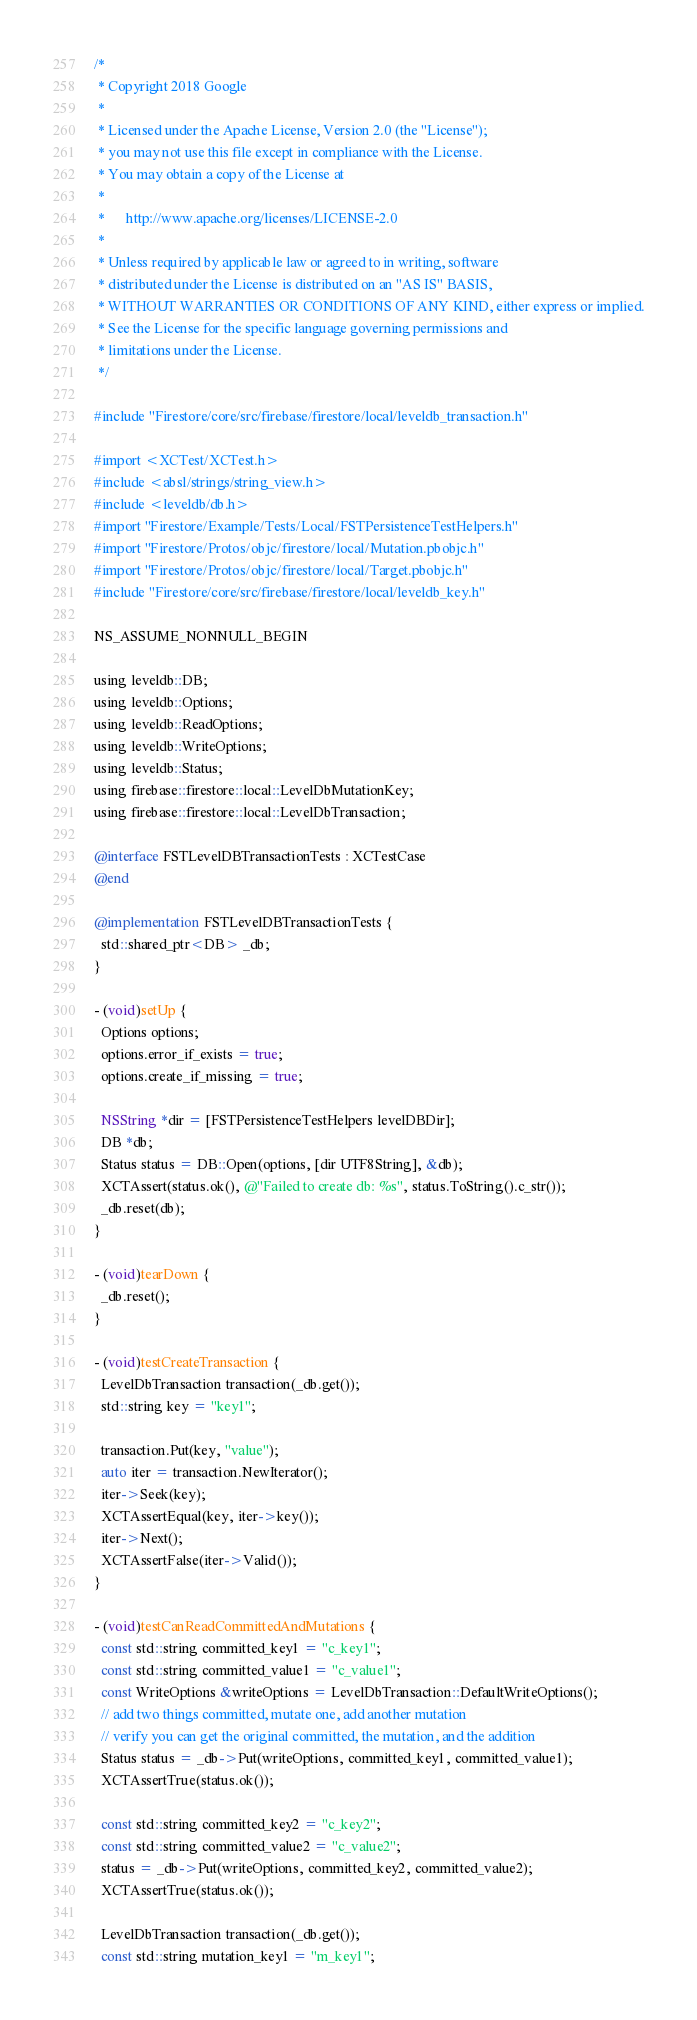<code> <loc_0><loc_0><loc_500><loc_500><_ObjectiveC_>/*
 * Copyright 2018 Google
 *
 * Licensed under the Apache License, Version 2.0 (the "License");
 * you may not use this file except in compliance with the License.
 * You may obtain a copy of the License at
 *
 *      http://www.apache.org/licenses/LICENSE-2.0
 *
 * Unless required by applicable law or agreed to in writing, software
 * distributed under the License is distributed on an "AS IS" BASIS,
 * WITHOUT WARRANTIES OR CONDITIONS OF ANY KIND, either express or implied.
 * See the License for the specific language governing permissions and
 * limitations under the License.
 */

#include "Firestore/core/src/firebase/firestore/local/leveldb_transaction.h"

#import <XCTest/XCTest.h>
#include <absl/strings/string_view.h>
#include <leveldb/db.h>
#import "Firestore/Example/Tests/Local/FSTPersistenceTestHelpers.h"
#import "Firestore/Protos/objc/firestore/local/Mutation.pbobjc.h"
#import "Firestore/Protos/objc/firestore/local/Target.pbobjc.h"
#include "Firestore/core/src/firebase/firestore/local/leveldb_key.h"

NS_ASSUME_NONNULL_BEGIN

using leveldb::DB;
using leveldb::Options;
using leveldb::ReadOptions;
using leveldb::WriteOptions;
using leveldb::Status;
using firebase::firestore::local::LevelDbMutationKey;
using firebase::firestore::local::LevelDbTransaction;

@interface FSTLevelDBTransactionTests : XCTestCase
@end

@implementation FSTLevelDBTransactionTests {
  std::shared_ptr<DB> _db;
}

- (void)setUp {
  Options options;
  options.error_if_exists = true;
  options.create_if_missing = true;

  NSString *dir = [FSTPersistenceTestHelpers levelDBDir];
  DB *db;
  Status status = DB::Open(options, [dir UTF8String], &db);
  XCTAssert(status.ok(), @"Failed to create db: %s", status.ToString().c_str());
  _db.reset(db);
}

- (void)tearDown {
  _db.reset();
}

- (void)testCreateTransaction {
  LevelDbTransaction transaction(_db.get());
  std::string key = "key1";

  transaction.Put(key, "value");
  auto iter = transaction.NewIterator();
  iter->Seek(key);
  XCTAssertEqual(key, iter->key());
  iter->Next();
  XCTAssertFalse(iter->Valid());
}

- (void)testCanReadCommittedAndMutations {
  const std::string committed_key1 = "c_key1";
  const std::string committed_value1 = "c_value1";
  const WriteOptions &writeOptions = LevelDbTransaction::DefaultWriteOptions();
  // add two things committed, mutate one, add another mutation
  // verify you can get the original committed, the mutation, and the addition
  Status status = _db->Put(writeOptions, committed_key1, committed_value1);
  XCTAssertTrue(status.ok());

  const std::string committed_key2 = "c_key2";
  const std::string committed_value2 = "c_value2";
  status = _db->Put(writeOptions, committed_key2, committed_value2);
  XCTAssertTrue(status.ok());

  LevelDbTransaction transaction(_db.get());
  const std::string mutation_key1 = "m_key1";</code> 